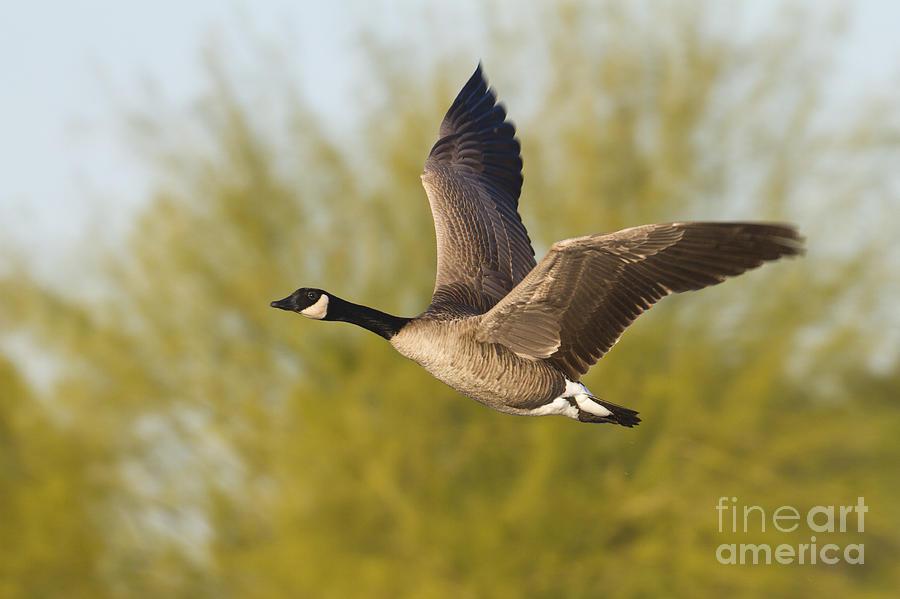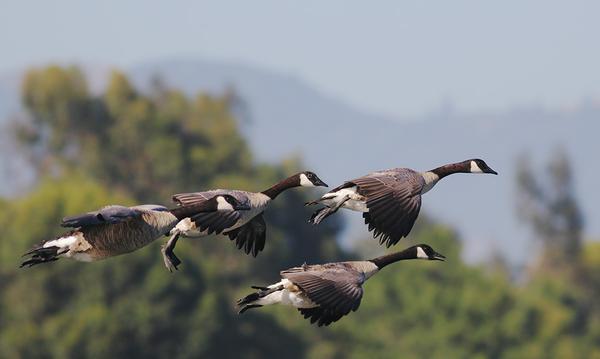The first image is the image on the left, the second image is the image on the right. Considering the images on both sides, is "All images show birds that are flying." valid? Answer yes or no. Yes. 